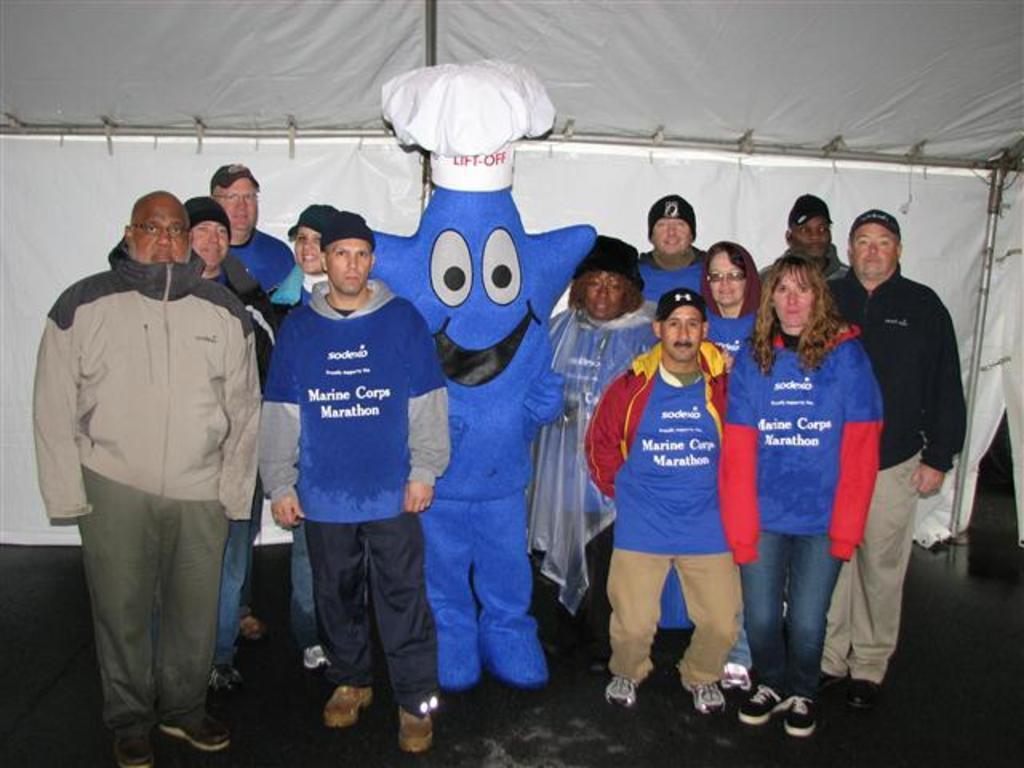In one or two sentences, can you explain what this image depicts? In this image we can see some persons, toy and other objects. In the background of the image there is a white background, iron object and other objects. At the bottom of the image there is the floor. 